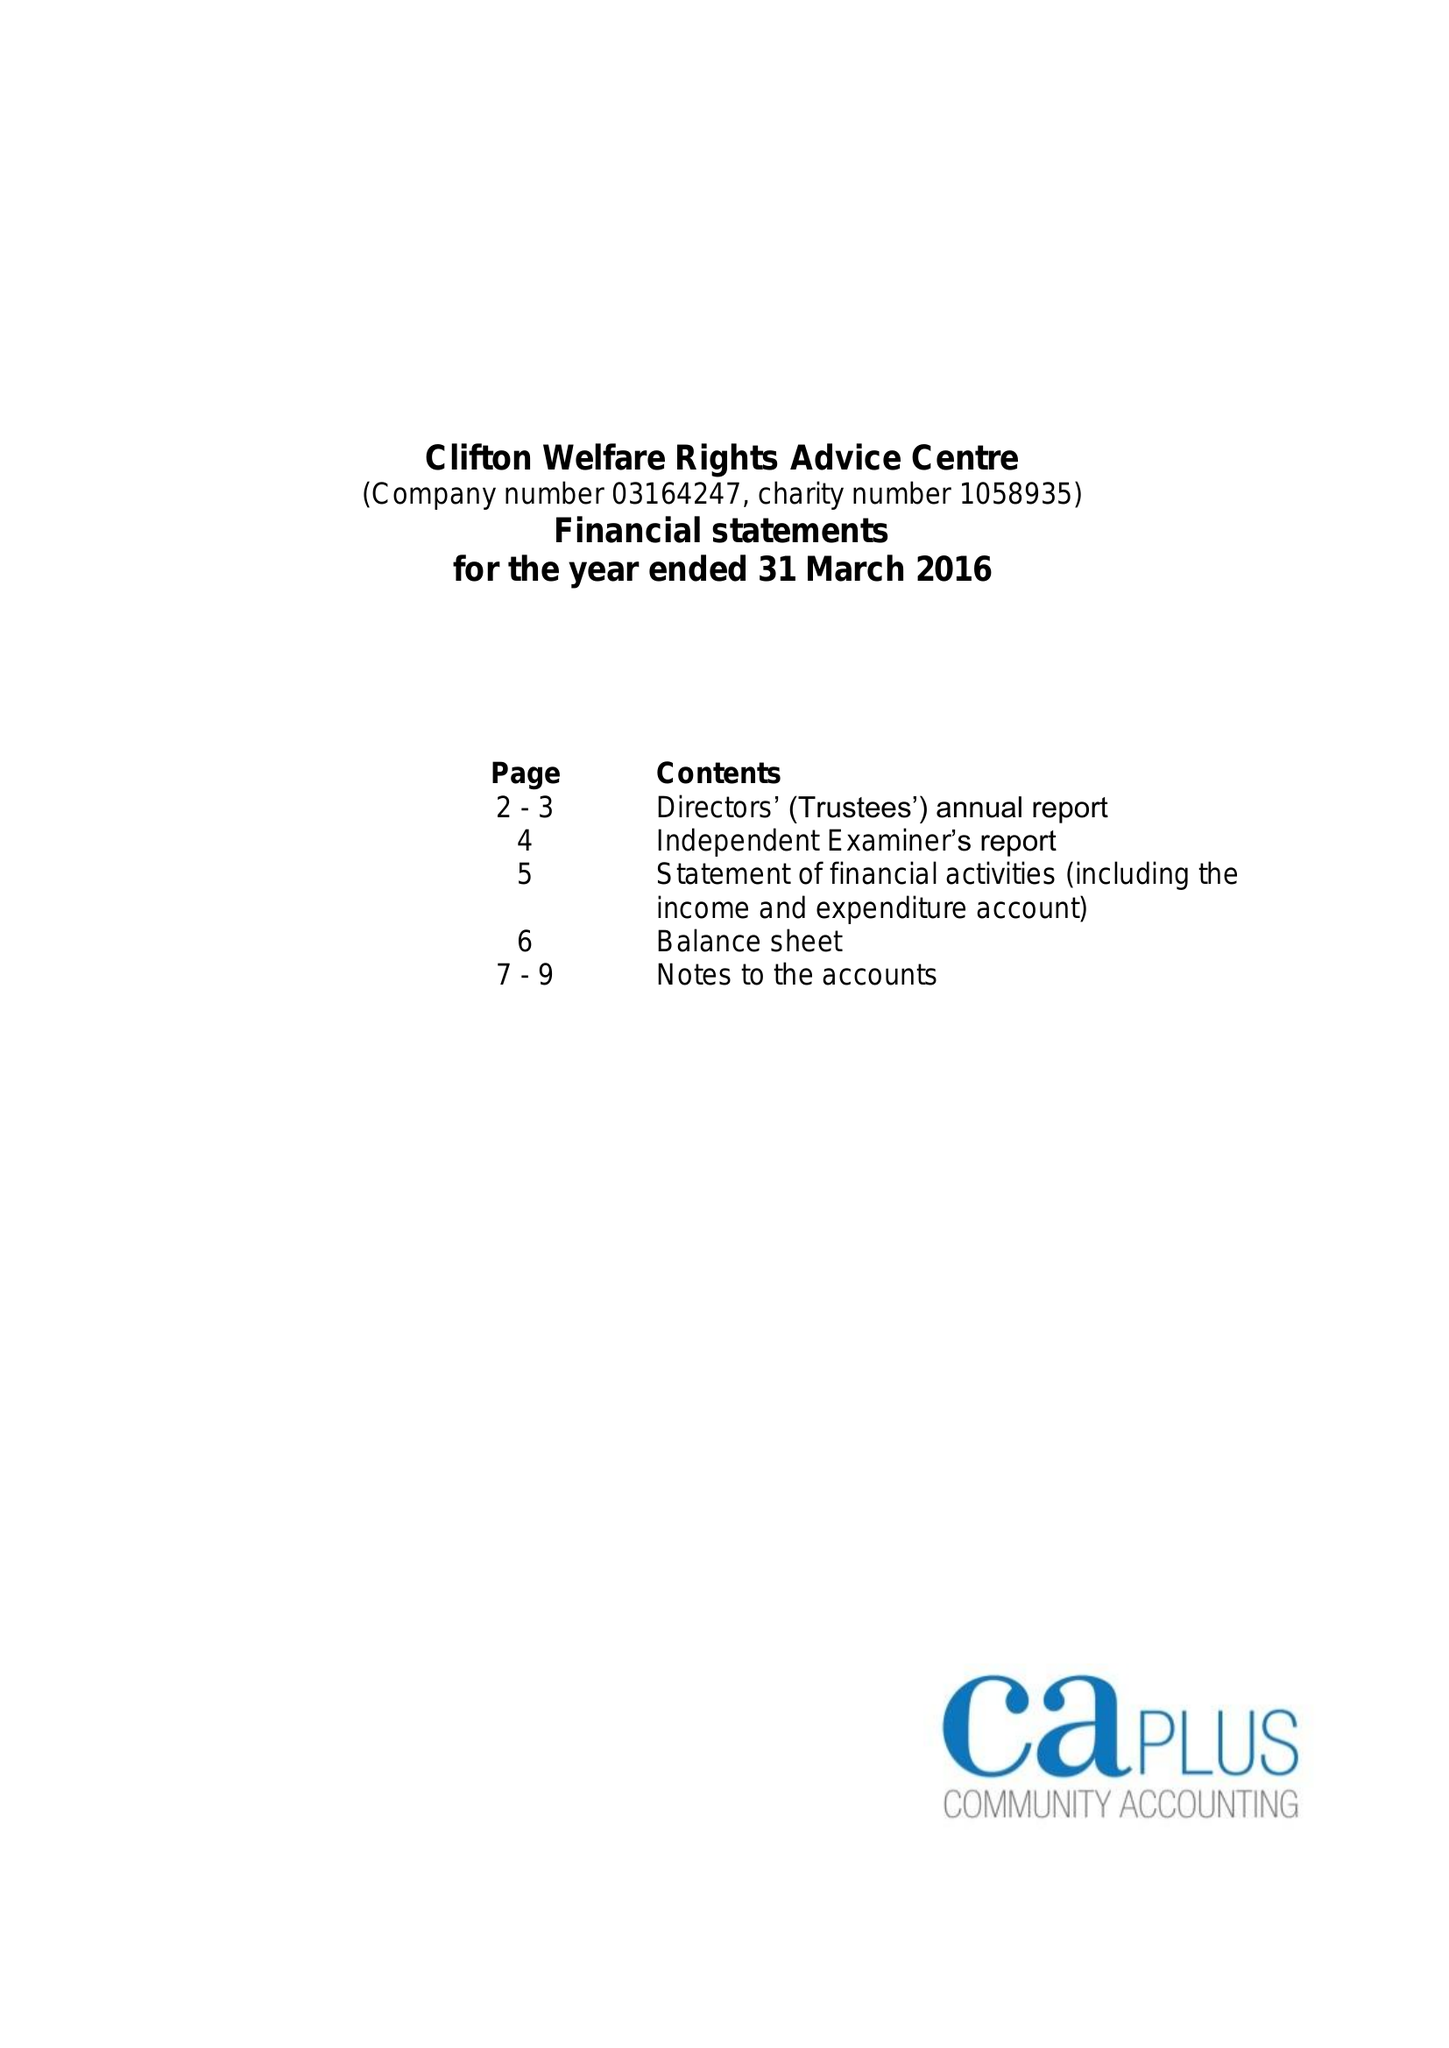What is the value for the spending_annually_in_british_pounds?
Answer the question using a single word or phrase. 84381.00 